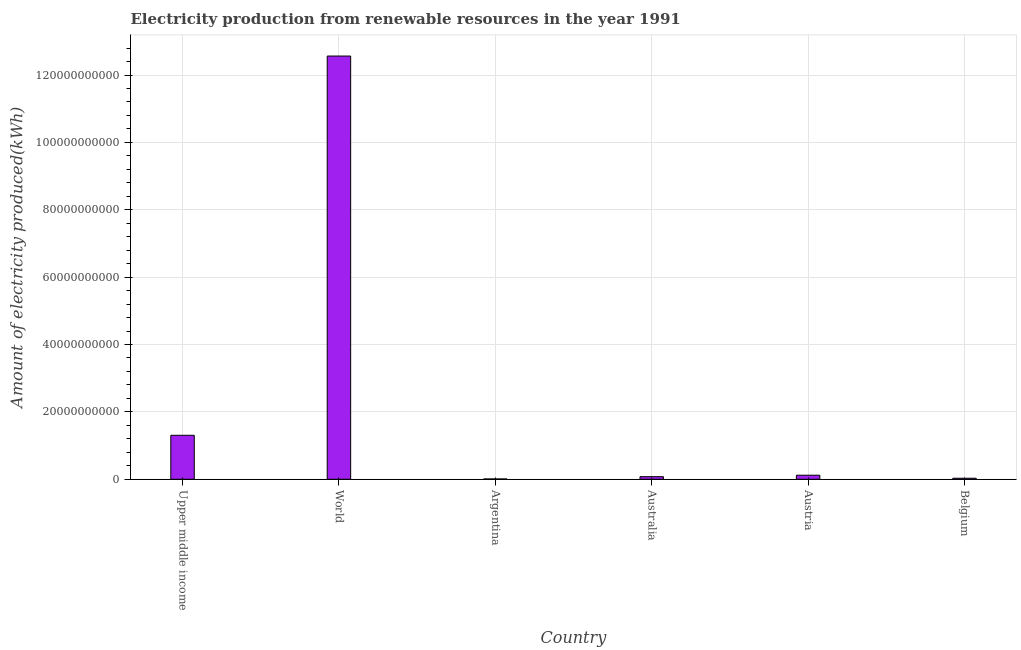What is the title of the graph?
Ensure brevity in your answer.  Electricity production from renewable resources in the year 1991. What is the label or title of the Y-axis?
Make the answer very short. Amount of electricity produced(kWh). Across all countries, what is the maximum amount of electricity produced?
Your answer should be very brief. 1.26e+11. Across all countries, what is the minimum amount of electricity produced?
Provide a succinct answer. 1.00e+08. What is the sum of the amount of electricity produced?
Your answer should be very brief. 1.41e+11. What is the difference between the amount of electricity produced in Austria and World?
Offer a very short reply. -1.24e+11. What is the average amount of electricity produced per country?
Make the answer very short. 2.35e+1. What is the median amount of electricity produced?
Give a very brief answer. 9.88e+08. In how many countries, is the amount of electricity produced greater than 100000000000 kWh?
Keep it short and to the point. 1. What is the ratio of the amount of electricity produced in Austria to that in Upper middle income?
Your answer should be very brief. 0.09. Is the difference between the amount of electricity produced in Australia and World greater than the difference between any two countries?
Ensure brevity in your answer.  No. What is the difference between the highest and the second highest amount of electricity produced?
Your answer should be very brief. 1.13e+11. What is the difference between the highest and the lowest amount of electricity produced?
Your answer should be compact. 1.26e+11. In how many countries, is the amount of electricity produced greater than the average amount of electricity produced taken over all countries?
Your response must be concise. 1. How many countries are there in the graph?
Offer a very short reply. 6. Are the values on the major ticks of Y-axis written in scientific E-notation?
Your answer should be compact. No. What is the Amount of electricity produced(kWh) in Upper middle income?
Give a very brief answer. 1.31e+1. What is the Amount of electricity produced(kWh) in World?
Offer a terse response. 1.26e+11. What is the Amount of electricity produced(kWh) in Australia?
Ensure brevity in your answer.  7.69e+08. What is the Amount of electricity produced(kWh) of Austria?
Make the answer very short. 1.21e+09. What is the Amount of electricity produced(kWh) in Belgium?
Offer a very short reply. 3.07e+08. What is the difference between the Amount of electricity produced(kWh) in Upper middle income and World?
Provide a short and direct response. -1.13e+11. What is the difference between the Amount of electricity produced(kWh) in Upper middle income and Argentina?
Your response must be concise. 1.30e+1. What is the difference between the Amount of electricity produced(kWh) in Upper middle income and Australia?
Your answer should be compact. 1.23e+1. What is the difference between the Amount of electricity produced(kWh) in Upper middle income and Austria?
Give a very brief answer. 1.18e+1. What is the difference between the Amount of electricity produced(kWh) in Upper middle income and Belgium?
Keep it short and to the point. 1.27e+1. What is the difference between the Amount of electricity produced(kWh) in World and Argentina?
Ensure brevity in your answer.  1.26e+11. What is the difference between the Amount of electricity produced(kWh) in World and Australia?
Your response must be concise. 1.25e+11. What is the difference between the Amount of electricity produced(kWh) in World and Austria?
Offer a very short reply. 1.24e+11. What is the difference between the Amount of electricity produced(kWh) in World and Belgium?
Your answer should be compact. 1.25e+11. What is the difference between the Amount of electricity produced(kWh) in Argentina and Australia?
Make the answer very short. -6.69e+08. What is the difference between the Amount of electricity produced(kWh) in Argentina and Austria?
Offer a very short reply. -1.11e+09. What is the difference between the Amount of electricity produced(kWh) in Argentina and Belgium?
Your answer should be very brief. -2.07e+08. What is the difference between the Amount of electricity produced(kWh) in Australia and Austria?
Make the answer very short. -4.37e+08. What is the difference between the Amount of electricity produced(kWh) in Australia and Belgium?
Your response must be concise. 4.62e+08. What is the difference between the Amount of electricity produced(kWh) in Austria and Belgium?
Offer a very short reply. 8.99e+08. What is the ratio of the Amount of electricity produced(kWh) in Upper middle income to that in World?
Make the answer very short. 0.1. What is the ratio of the Amount of electricity produced(kWh) in Upper middle income to that in Argentina?
Provide a succinct answer. 130.56. What is the ratio of the Amount of electricity produced(kWh) in Upper middle income to that in Australia?
Your answer should be compact. 16.98. What is the ratio of the Amount of electricity produced(kWh) in Upper middle income to that in Austria?
Provide a short and direct response. 10.83. What is the ratio of the Amount of electricity produced(kWh) in Upper middle income to that in Belgium?
Your response must be concise. 42.53. What is the ratio of the Amount of electricity produced(kWh) in World to that in Argentina?
Your response must be concise. 1256.31. What is the ratio of the Amount of electricity produced(kWh) in World to that in Australia?
Offer a terse response. 163.37. What is the ratio of the Amount of electricity produced(kWh) in World to that in Austria?
Keep it short and to the point. 104.17. What is the ratio of the Amount of electricity produced(kWh) in World to that in Belgium?
Make the answer very short. 409.22. What is the ratio of the Amount of electricity produced(kWh) in Argentina to that in Australia?
Ensure brevity in your answer.  0.13. What is the ratio of the Amount of electricity produced(kWh) in Argentina to that in Austria?
Offer a terse response. 0.08. What is the ratio of the Amount of electricity produced(kWh) in Argentina to that in Belgium?
Provide a succinct answer. 0.33. What is the ratio of the Amount of electricity produced(kWh) in Australia to that in Austria?
Make the answer very short. 0.64. What is the ratio of the Amount of electricity produced(kWh) in Australia to that in Belgium?
Your answer should be very brief. 2.5. What is the ratio of the Amount of electricity produced(kWh) in Austria to that in Belgium?
Provide a succinct answer. 3.93. 